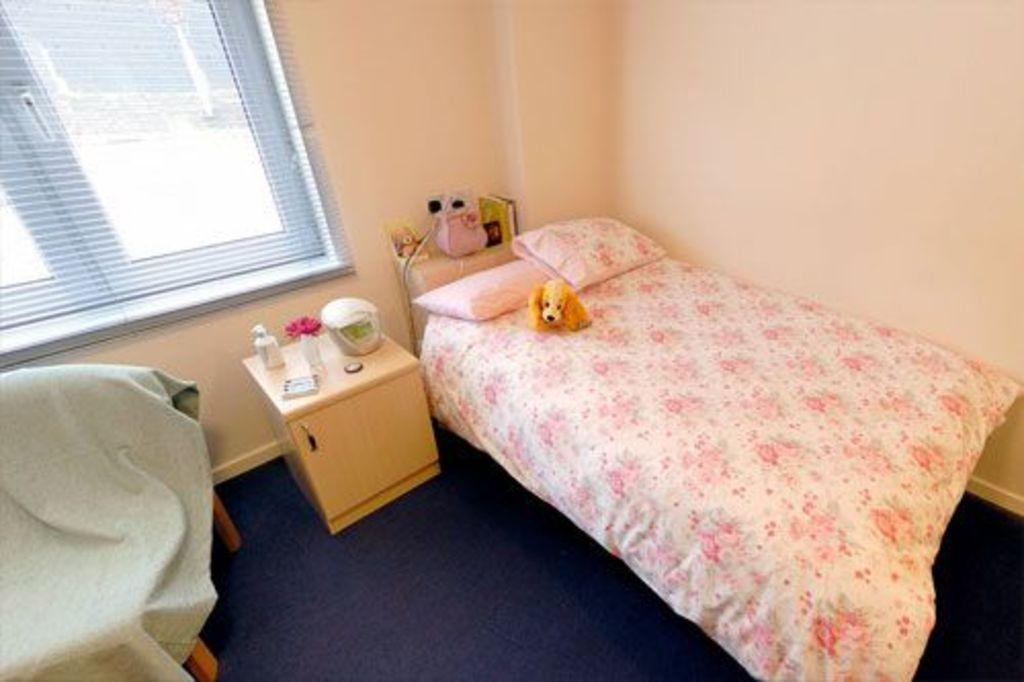What piece of furniture is present in the image for sleeping? There is a bed in the image. What items are on the bed? There are pillows on the bed. What other piece of furniture is present in the image? There is a table and a chair in the image. What is on the chair? There is a blanket on the chair. What architectural features can be seen in the image? There is a window and a wall in the image. How many pigs are visible in the image? There are no pigs present in the image. What time of day is it in the image, as indicated by the hour? There is no clock or indication of time in the image, so it is not possible to determine the hour. 